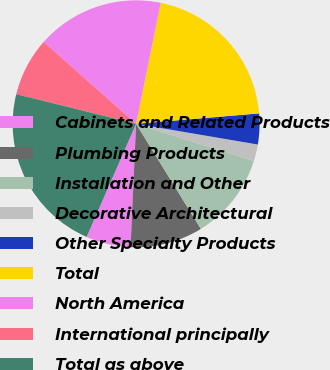<chart> <loc_0><loc_0><loc_500><loc_500><pie_chart><fcel>Cabinets and Related Products<fcel>Plumbing Products<fcel>Installation and Other<fcel>Decorative Architectural<fcel>Other Specialty Products<fcel>Total<fcel>North America<fcel>International principally<fcel>Total as above<nl><fcel>5.85%<fcel>9.5%<fcel>11.33%<fcel>2.2%<fcel>4.03%<fcel>20.46%<fcel>16.65%<fcel>7.68%<fcel>22.29%<nl></chart> 